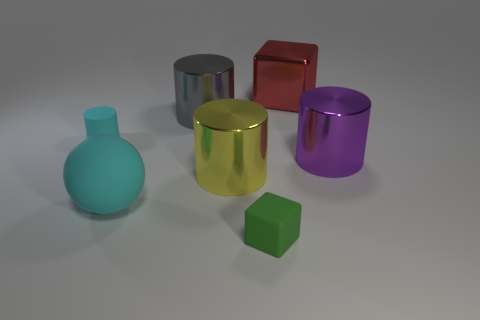There is a rubber object that is the same color as the large matte ball; what is its shape?
Make the answer very short. Cylinder. Is there anything else that is made of the same material as the small green object?
Your answer should be very brief. Yes. What material is the cube that is behind the cylinder that is right of the red metal object?
Offer a very short reply. Metal. There is a block behind the large cylinder behind the tiny matte object behind the large cyan thing; what is its size?
Offer a terse response. Large. What number of other things are there of the same shape as the gray shiny thing?
Ensure brevity in your answer.  3. There is a object behind the big gray metal cylinder; is its color the same as the thing that is in front of the cyan sphere?
Ensure brevity in your answer.  No. The object that is the same size as the green rubber block is what color?
Make the answer very short. Cyan. Is there a metallic cylinder that has the same color as the tiny matte cylinder?
Offer a very short reply. No. There is a cube behind the yellow metal cylinder; is it the same size as the large purple object?
Offer a very short reply. Yes. Are there the same number of big metal objects in front of the tiny green matte cube and small blue rubber things?
Your response must be concise. Yes. 